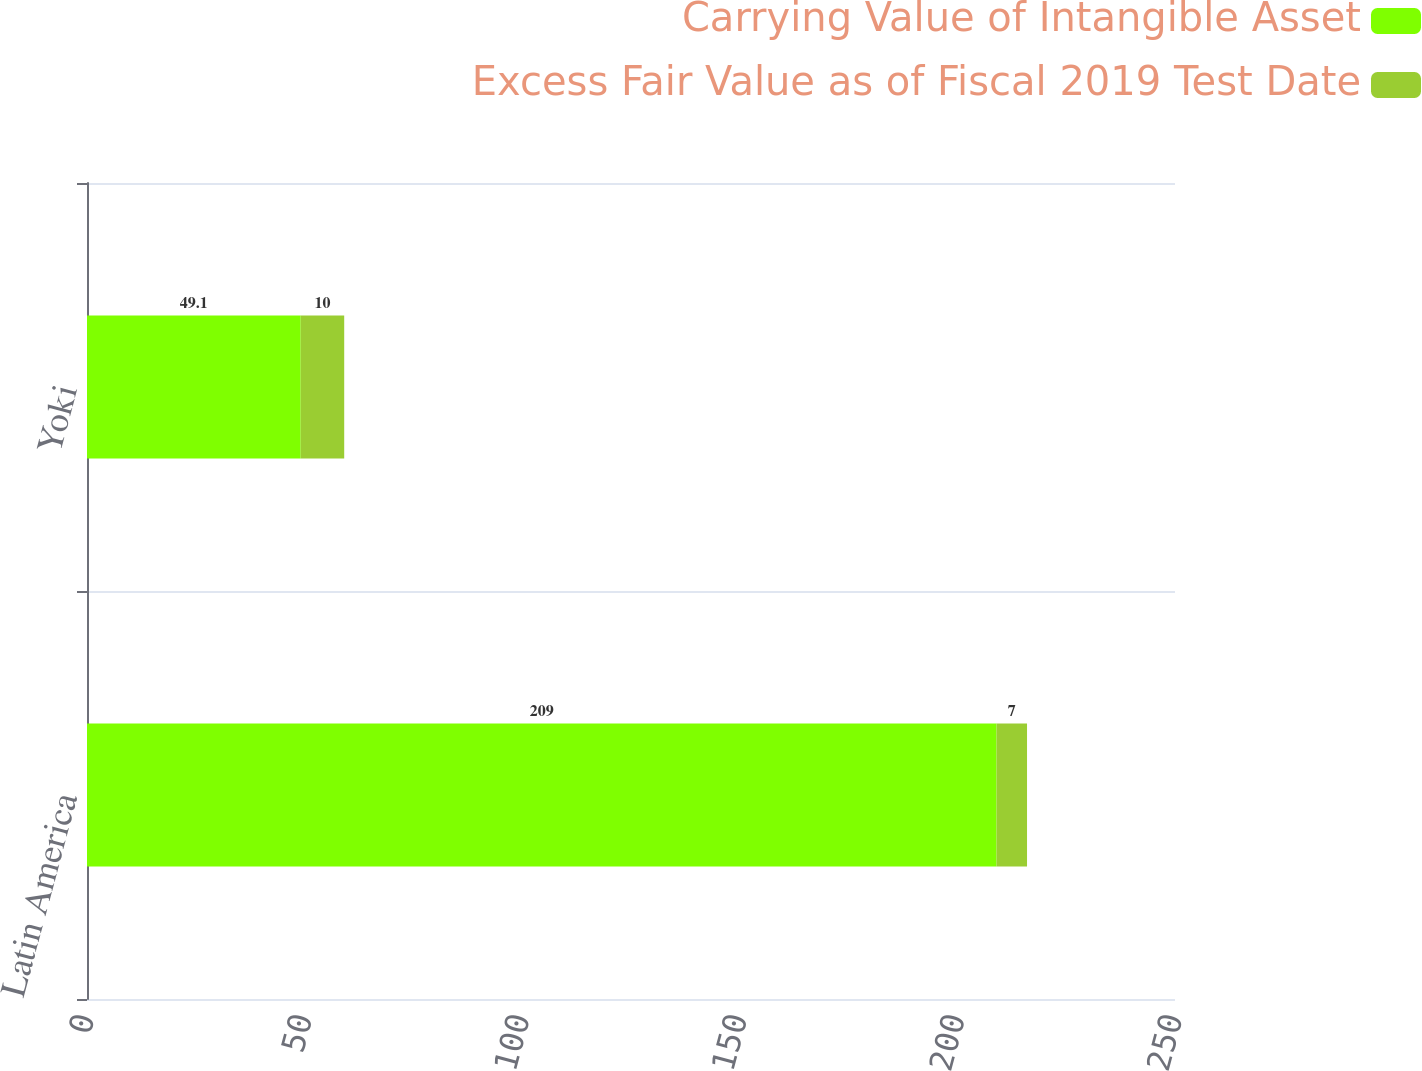Convert chart. <chart><loc_0><loc_0><loc_500><loc_500><stacked_bar_chart><ecel><fcel>Latin America<fcel>Yoki<nl><fcel>Carrying Value of Intangible Asset<fcel>209<fcel>49.1<nl><fcel>Excess Fair Value as of Fiscal 2019 Test Date<fcel>7<fcel>10<nl></chart> 